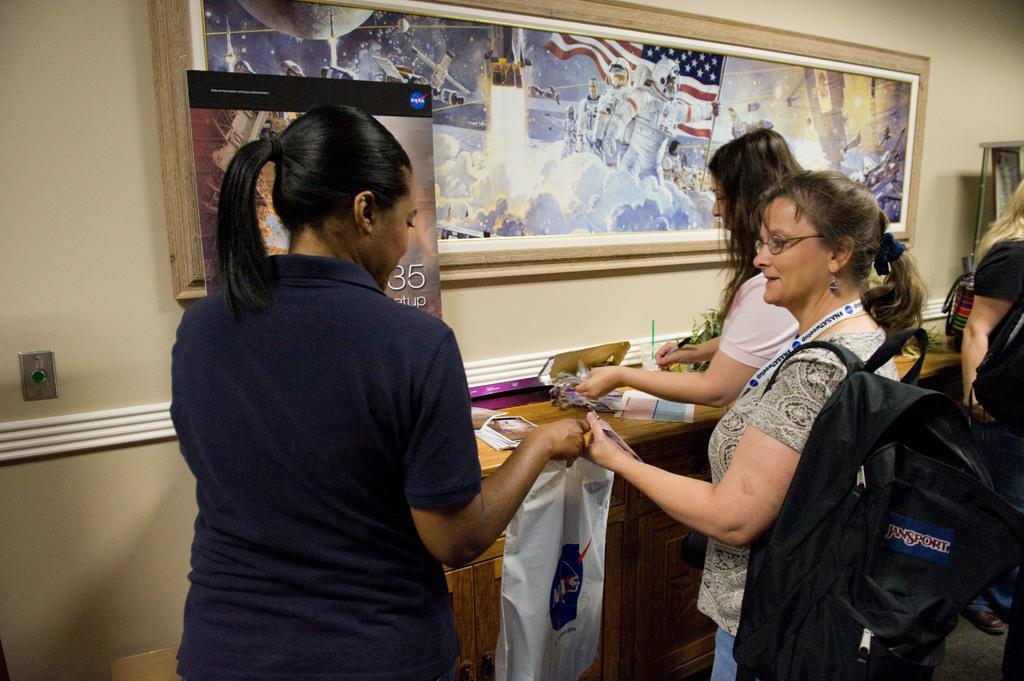How would you summarize this image in a sentence or two? This image is taken indoors. In the background there is a wall with a picture frame on it. There is a banner with a text on it. There is a table with a few things on it. On the left side of the image a woman is standing and she is holding a cover in her hand. On the right side of the image there are a few people. In the middle of the image to women are standing a woman is holding a pen in her hand and writing. A woman is holding a cover and she has worn a backpack. 